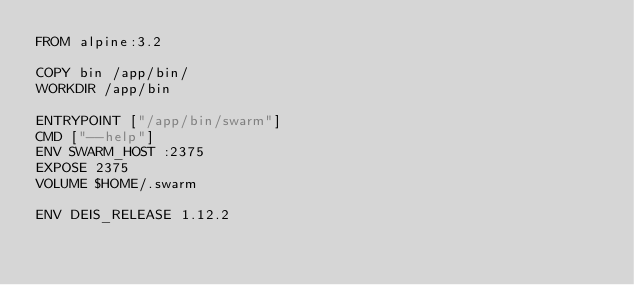Convert code to text. <code><loc_0><loc_0><loc_500><loc_500><_Dockerfile_>FROM alpine:3.2

COPY bin /app/bin/
WORKDIR /app/bin

ENTRYPOINT ["/app/bin/swarm"]
CMD ["--help"]
ENV SWARM_HOST :2375
EXPOSE 2375
VOLUME $HOME/.swarm

ENV DEIS_RELEASE 1.12.2
</code> 